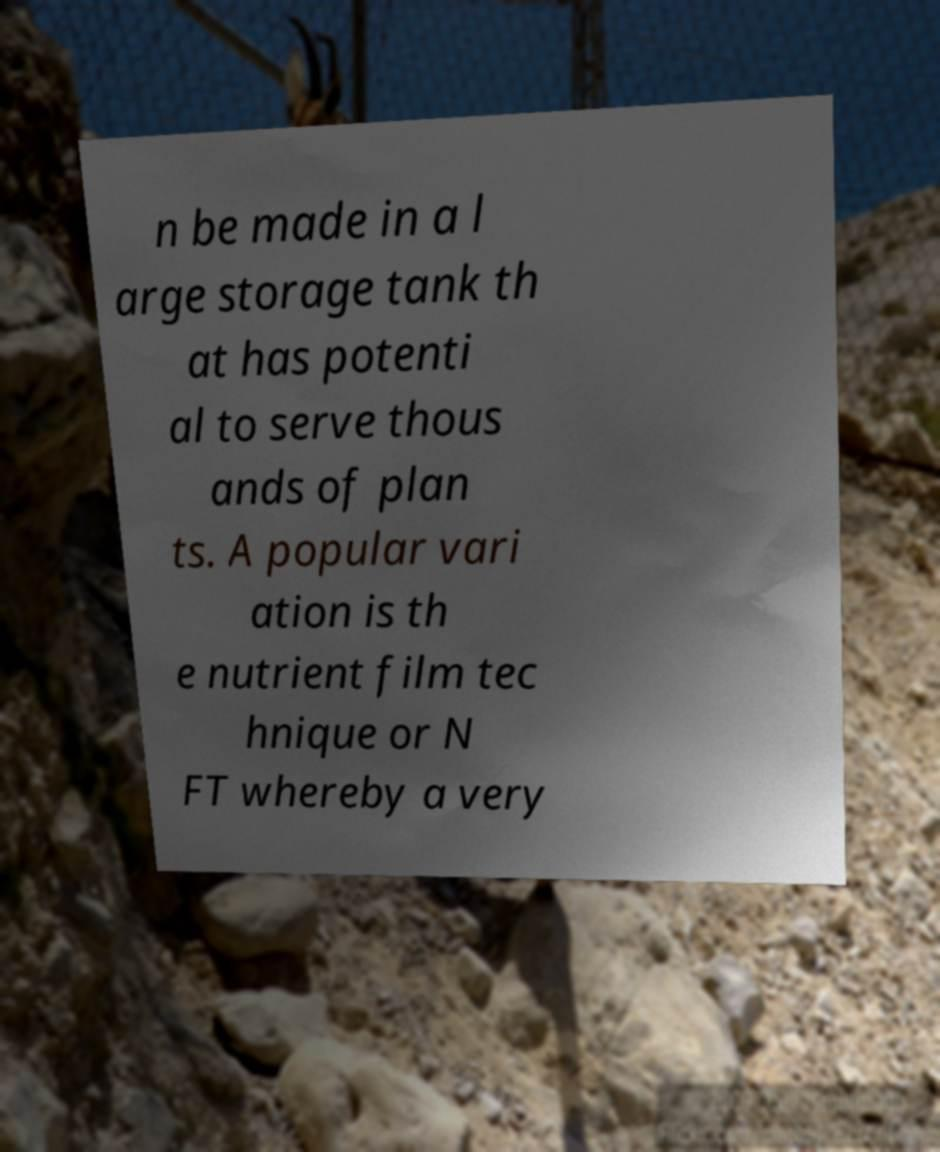What messages or text are displayed in this image? I need them in a readable, typed format. n be made in a l arge storage tank th at has potenti al to serve thous ands of plan ts. A popular vari ation is th e nutrient film tec hnique or N FT whereby a very 